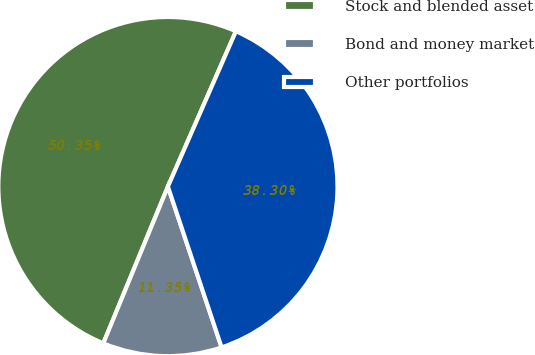<chart> <loc_0><loc_0><loc_500><loc_500><pie_chart><fcel>Stock and blended asset<fcel>Bond and money market<fcel>Other portfolios<nl><fcel>50.34%<fcel>11.35%<fcel>38.3%<nl></chart> 